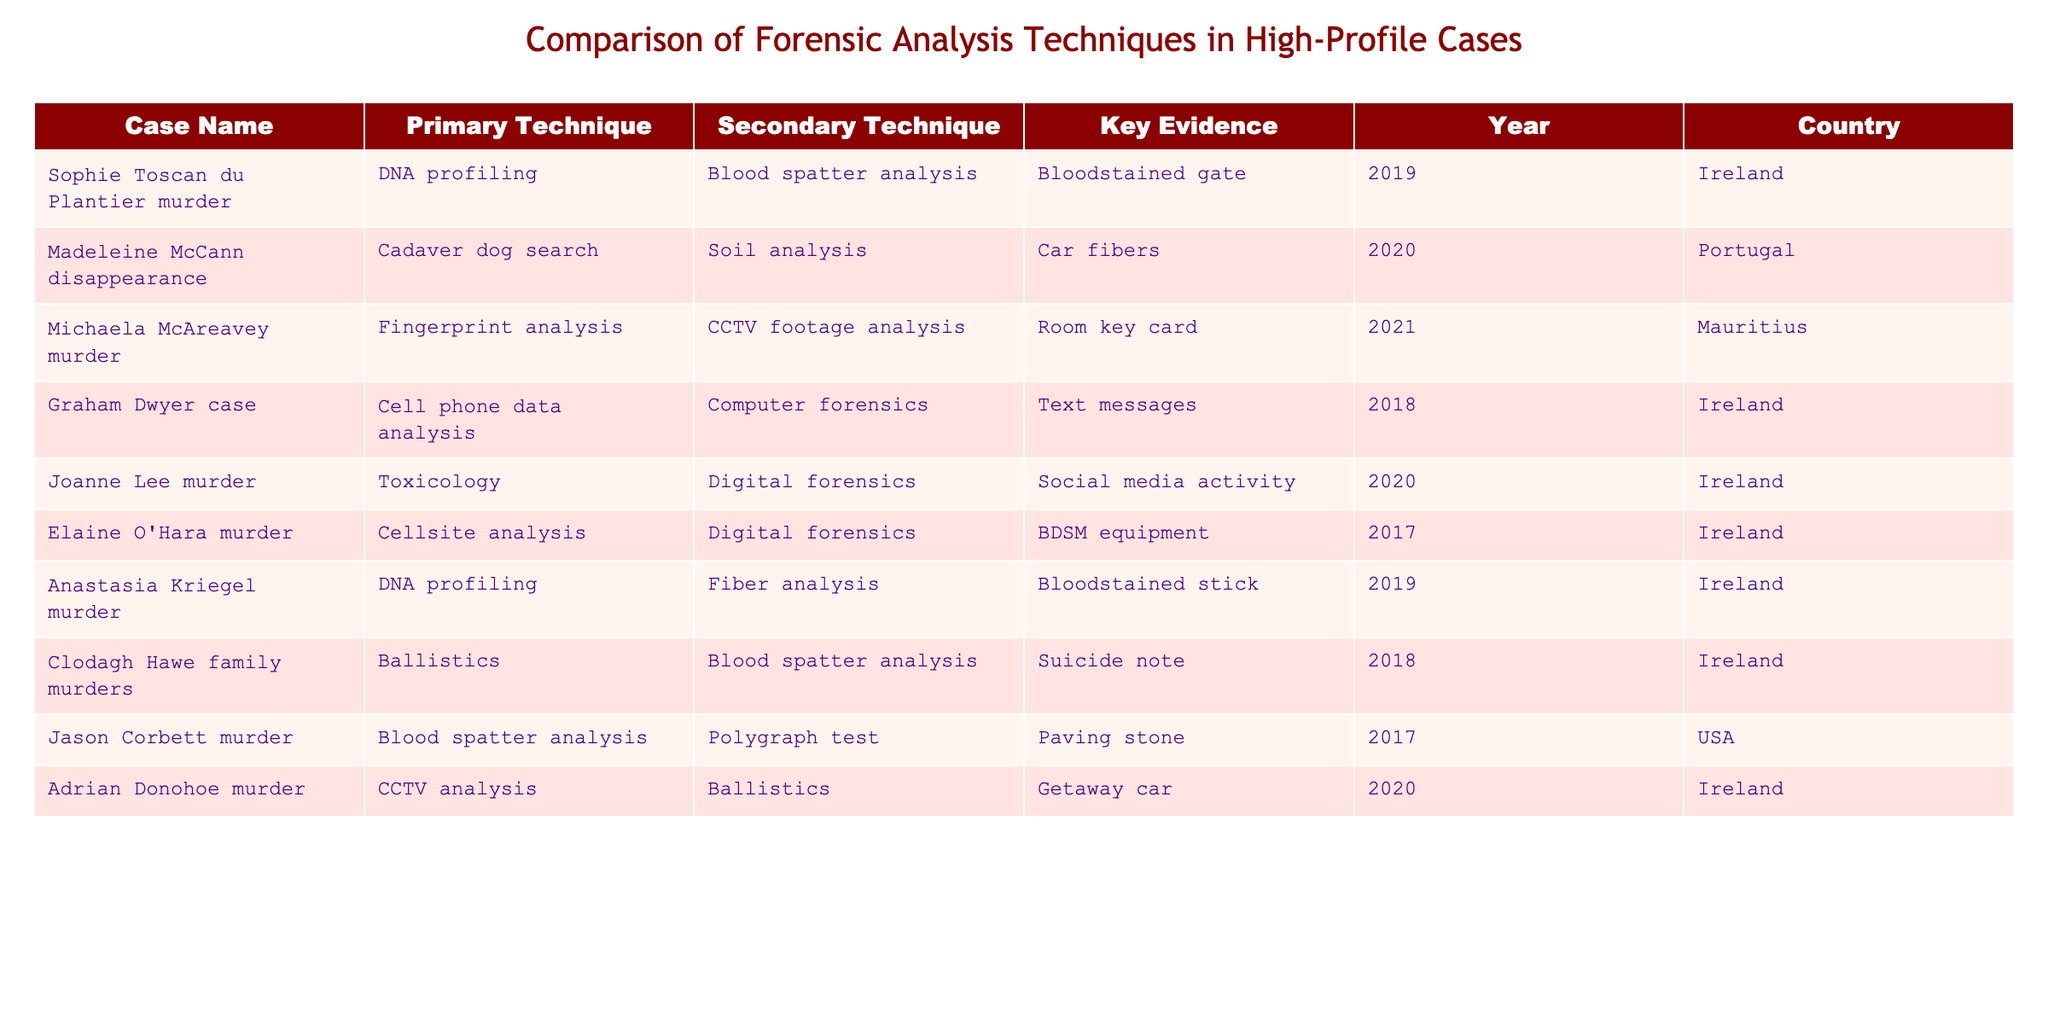What is the primary technique used in the Graham Dwyer case? Referring to the table, the row corresponding to the Graham Dwyer case lists the primary technique as "Cell phone data analysis."
Answer: Cell phone data analysis Which case used DNA profiling as a primary technique? Looking through the table, the cases associated with DNA profiling as the primary technique are the Sophie Toscan du Plantier murder and the Anastasia Kriegel murder.
Answer: Sophie Toscan du Plantier murder and Anastasia Kriegel murder How many cases used blood spatter analysis as the primary technique? By examining the table, we see that blood spatter analysis is listed as the primary technique for the Sophie Toscan du Plantier murder, the Michaela McAreavey murder, and the Jason Corbett murder, totaling three cases.
Answer: Three Is the secondary technique for the Joanne Lee murder digital forensics? In the table, the secondary technique for the Joanne Lee murder is listed as "Digital forensics," confirming that the statement is true.
Answer: Yes What is the key evidence in the Madeleine McCann disappearance and which primary technique was used? The table indicates that key evidence for the Madeleine McCann disappearance is "Car fibers," with the primary technique being "Cadaver dog search."
Answer: Car fibers; Cadaver dog search Which country had the most cases listed in the table? Upon reviewing the table, we see that Ireland appears in seven cases, while Portugal and the USA have one case each, making Ireland the country with the most cases listed.
Answer: Ireland What is the difference in the number of cases between those that used DNA profiling and those that used fingerprint analysis? DNA profiling was used in two cases (Sophie Toscan du Plantier and Anastasia Kriegel) and fingerprint analysis was used in one case (Michaela McAreavey). Thus, the difference is 2 - 1 = 1.
Answer: 1 In how many of the cases listed was digital forensics a secondary technique? The examination of the table shows that digital forensics was a secondary technique in the Joanne Lee murder and the Elaine O'Hara murder, resulting in two cases.
Answer: Two Which primary technique had the least occurrences in the table? By analyzing the table, we determine that techniques such as polygraph test, soil analysis, and fingerprint analysis each appear only once, indicating they are the least common.
Answer: Polygraph test, soil analysis, fingerprint analysis How many cases occurred between 2017 and 2020, and what percentage of all cases does that represent? There are six cases listed from the years 2017 to 2020 (Elaine O'Hara murder, Adrian Donohoe case, etc.), and there are a total of ten cases. To find the percentage, we calculate (6/10)*100 = 60%.
Answer: 60% 